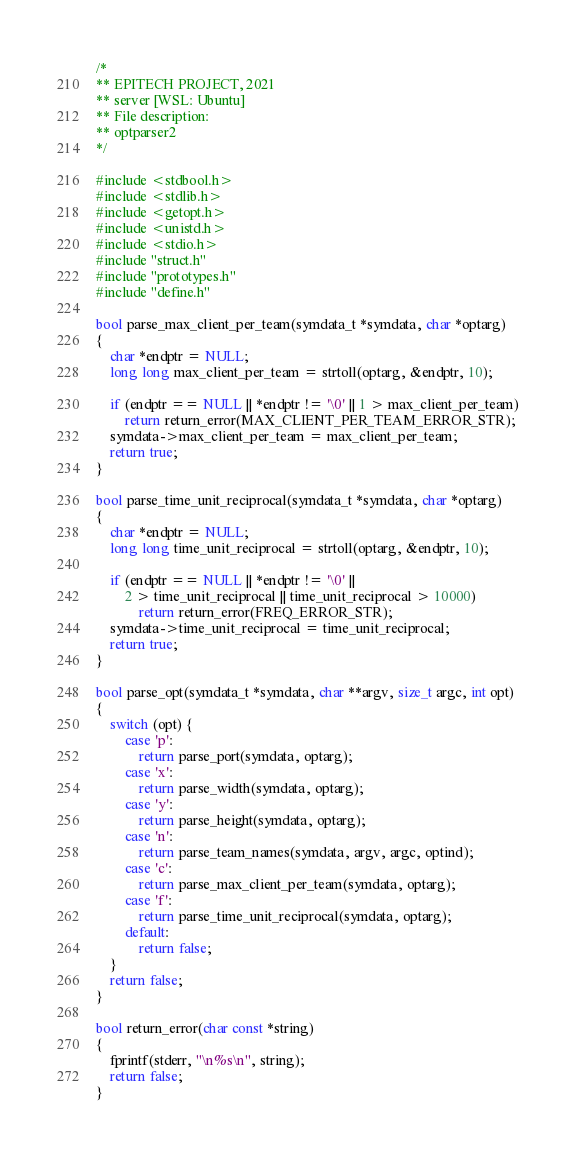Convert code to text. <code><loc_0><loc_0><loc_500><loc_500><_C_>/*
** EPITECH PROJECT, 2021
** server [WSL: Ubuntu]
** File description:
** optparser2
*/

#include <stdbool.h>
#include <stdlib.h>
#include <getopt.h>
#include <unistd.h>
#include <stdio.h>
#include "struct.h"
#include "prototypes.h"
#include "define.h"

bool parse_max_client_per_team(symdata_t *symdata, char *optarg)
{
    char *endptr = NULL;
    long long max_client_per_team = strtoll(optarg, &endptr, 10);

    if (endptr == NULL || *endptr != '\0' || 1 > max_client_per_team)
        return return_error(MAX_CLIENT_PER_TEAM_ERROR_STR);
    symdata->max_client_per_team = max_client_per_team;
    return true;
}

bool parse_time_unit_reciprocal(symdata_t *symdata, char *optarg)
{
    char *endptr = NULL;
    long long time_unit_reciprocal = strtoll(optarg, &endptr, 10);

    if (endptr == NULL || *endptr != '\0' ||
        2 > time_unit_reciprocal || time_unit_reciprocal > 10000)
            return return_error(FREQ_ERROR_STR);
    symdata->time_unit_reciprocal = time_unit_reciprocal;
    return true;
}

bool parse_opt(symdata_t *symdata, char **argv, size_t argc, int opt)
{
    switch (opt) {
        case 'p':
            return parse_port(symdata, optarg);
        case 'x':
            return parse_width(symdata, optarg);
        case 'y':
            return parse_height(symdata, optarg);
        case 'n':
            return parse_team_names(symdata, argv, argc, optind);
        case 'c':
            return parse_max_client_per_team(symdata, optarg);
        case 'f':
            return parse_time_unit_reciprocal(symdata, optarg);
        default:
            return false;
    }
    return false;
}

bool return_error(char const *string)
{
    fprintf(stderr, "\n%s\n", string);
    return false;
}</code> 